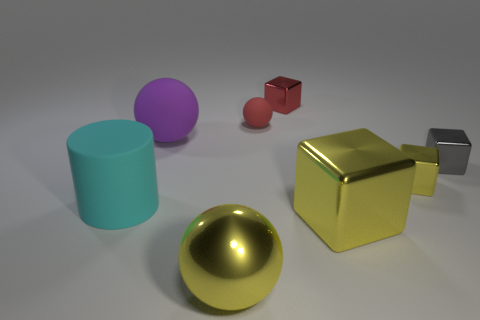How many yellow blocks must be subtracted to get 1 yellow blocks? 1 Add 1 purple objects. How many objects exist? 9 Subtract all balls. How many objects are left? 5 Add 2 small gray objects. How many small gray objects are left? 3 Add 6 large yellow objects. How many large yellow objects exist? 8 Subtract 1 red balls. How many objects are left? 7 Subtract all tiny metallic blocks. Subtract all large blocks. How many objects are left? 4 